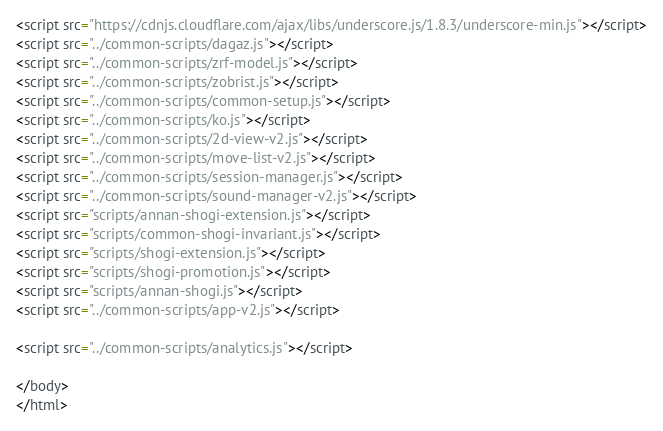Convert code to text. <code><loc_0><loc_0><loc_500><loc_500><_HTML_><script src="https://cdnjs.cloudflare.com/ajax/libs/underscore.js/1.8.3/underscore-min.js"></script>
<script src="../common-scripts/dagaz.js"></script>
<script src="../common-scripts/zrf-model.js"></script>
<script src="../common-scripts/zobrist.js"></script>
<script src="../common-scripts/common-setup.js"></script>
<script src="../common-scripts/ko.js"></script>
<script src="../common-scripts/2d-view-v2.js"></script>
<script src="../common-scripts/move-list-v2.js"></script>
<script src="../common-scripts/session-manager.js"></script>
<script src="../common-scripts/sound-manager-v2.js"></script>
<script src="scripts/annan-shogi-extension.js"></script>
<script src="scripts/common-shogi-invariant.js"></script>
<script src="scripts/shogi-extension.js"></script>
<script src="scripts/shogi-promotion.js"></script>
<script src="scripts/annan-shogi.js"></script>
<script src="../common-scripts/app-v2.js"></script>

<script src="../common-scripts/analytics.js"></script>

</body>
</html>
</code> 